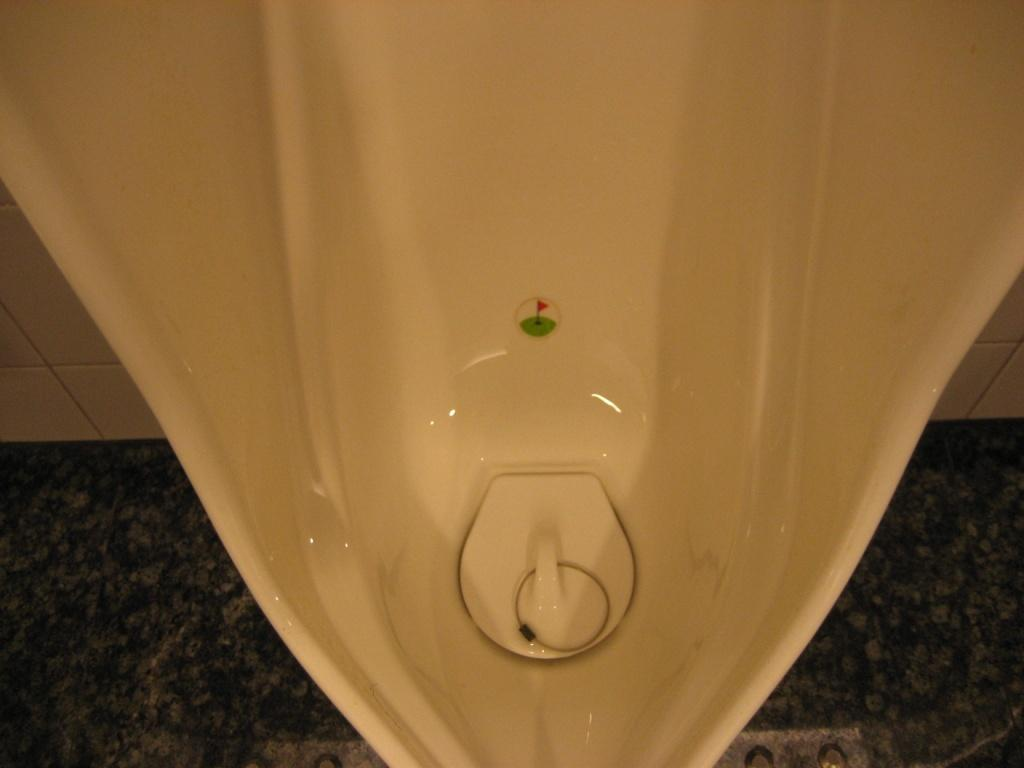What is the main subject of the image? The main subject of the image is a urinal. Where is the urinal located in the image? The urinal is in the center of the image. What type of icicle can be seen hanging from the urinal in the image? There is no icicle present in the image; it is a urinal without any additional elements. 